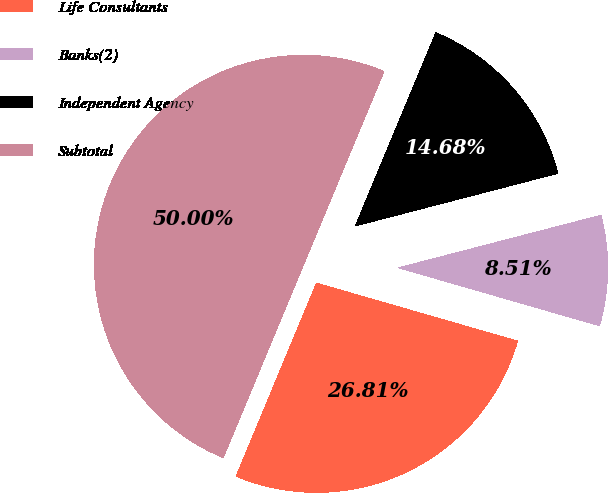Convert chart to OTSL. <chart><loc_0><loc_0><loc_500><loc_500><pie_chart><fcel>Life Consultants<fcel>Banks(2)<fcel>Independent Agency<fcel>Subtotal<nl><fcel>26.81%<fcel>8.51%<fcel>14.68%<fcel>50.0%<nl></chart> 